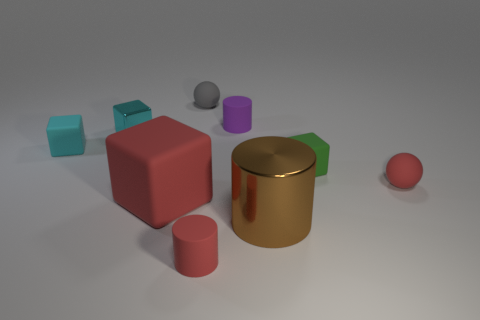What number of other objects are the same color as the metal cube?
Offer a terse response. 1. How many matte objects are yellow cylinders or cylinders?
Offer a very short reply. 2. There is a shiny object in front of the cyan rubber cube; what is its size?
Your answer should be very brief. Large. Is the shape of the cyan metallic thing the same as the purple rubber thing?
Your answer should be compact. No. What number of large objects are balls or matte blocks?
Your response must be concise. 1. There is a small cyan shiny cube; are there any large metallic cylinders in front of it?
Keep it short and to the point. Yes. Are there an equal number of small balls in front of the green matte object and tiny green rubber cubes?
Offer a very short reply. Yes. The brown metal thing that is the same shape as the purple rubber object is what size?
Provide a succinct answer. Large. There is a green thing; is it the same shape as the matte object to the left of the large red block?
Offer a terse response. Yes. What size is the red cube right of the metal object behind the large block?
Give a very brief answer. Large. 